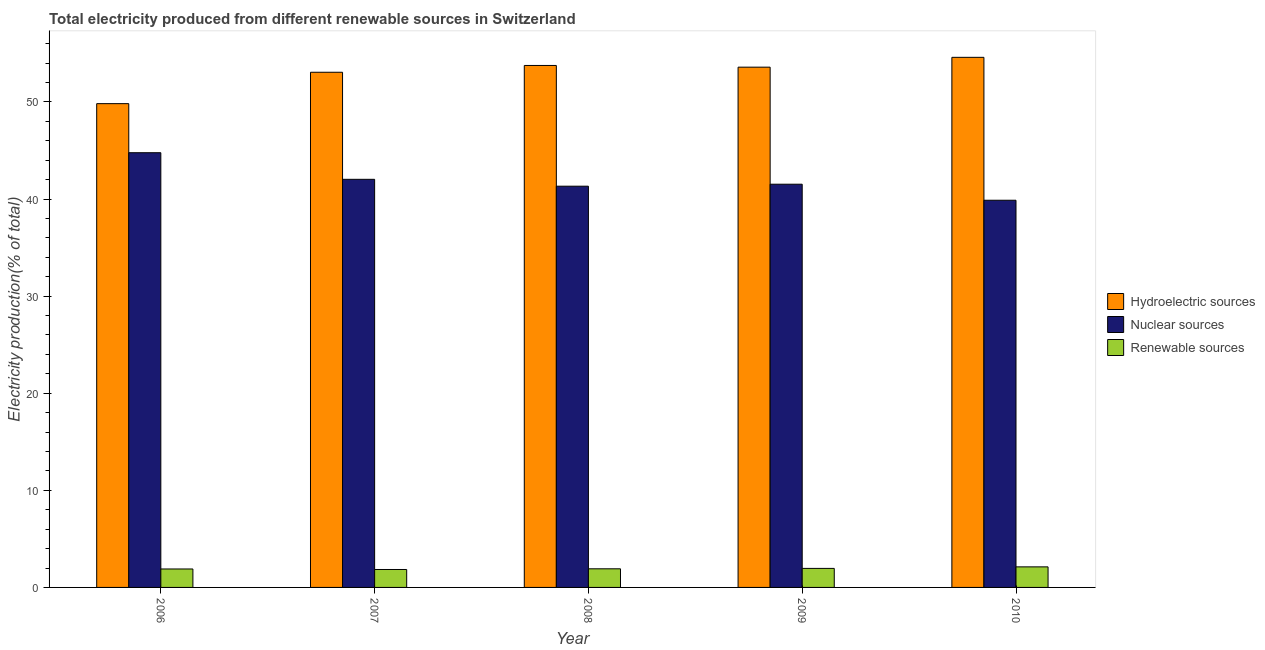How many groups of bars are there?
Ensure brevity in your answer.  5. Are the number of bars on each tick of the X-axis equal?
Your answer should be compact. Yes. How many bars are there on the 1st tick from the right?
Your response must be concise. 3. What is the label of the 5th group of bars from the left?
Give a very brief answer. 2010. What is the percentage of electricity produced by hydroelectric sources in 2008?
Offer a terse response. 53.76. Across all years, what is the maximum percentage of electricity produced by renewable sources?
Your response must be concise. 2.12. Across all years, what is the minimum percentage of electricity produced by renewable sources?
Ensure brevity in your answer.  1.85. In which year was the percentage of electricity produced by nuclear sources minimum?
Give a very brief answer. 2010. What is the total percentage of electricity produced by renewable sources in the graph?
Your answer should be compact. 9.74. What is the difference between the percentage of electricity produced by hydroelectric sources in 2006 and that in 2008?
Provide a short and direct response. -3.93. What is the difference between the percentage of electricity produced by hydroelectric sources in 2007 and the percentage of electricity produced by nuclear sources in 2009?
Make the answer very short. -0.52. What is the average percentage of electricity produced by hydroelectric sources per year?
Your answer should be compact. 52.96. In how many years, is the percentage of electricity produced by hydroelectric sources greater than 28 %?
Keep it short and to the point. 5. What is the ratio of the percentage of electricity produced by nuclear sources in 2007 to that in 2009?
Ensure brevity in your answer.  1.01. Is the percentage of electricity produced by renewable sources in 2006 less than that in 2009?
Provide a short and direct response. Yes. What is the difference between the highest and the second highest percentage of electricity produced by renewable sources?
Provide a succinct answer. 0.16. What is the difference between the highest and the lowest percentage of electricity produced by hydroelectric sources?
Keep it short and to the point. 4.77. What does the 1st bar from the left in 2009 represents?
Provide a succinct answer. Hydroelectric sources. What does the 3rd bar from the right in 2006 represents?
Keep it short and to the point. Hydroelectric sources. How many bars are there?
Offer a terse response. 15. Are all the bars in the graph horizontal?
Make the answer very short. No. How many years are there in the graph?
Make the answer very short. 5. What is the difference between two consecutive major ticks on the Y-axis?
Provide a succinct answer. 10. Does the graph contain any zero values?
Ensure brevity in your answer.  No. Does the graph contain grids?
Ensure brevity in your answer.  No. Where does the legend appear in the graph?
Make the answer very short. Center right. How are the legend labels stacked?
Keep it short and to the point. Vertical. What is the title of the graph?
Ensure brevity in your answer.  Total electricity produced from different renewable sources in Switzerland. Does "Labor Market" appear as one of the legend labels in the graph?
Offer a very short reply. No. What is the Electricity production(% of total) of Hydroelectric sources in 2006?
Make the answer very short. 49.83. What is the Electricity production(% of total) in Nuclear sources in 2006?
Your answer should be compact. 44.77. What is the Electricity production(% of total) in Renewable sources in 2006?
Keep it short and to the point. 1.9. What is the Electricity production(% of total) in Hydroelectric sources in 2007?
Offer a very short reply. 53.06. What is the Electricity production(% of total) of Nuclear sources in 2007?
Provide a succinct answer. 42.03. What is the Electricity production(% of total) in Renewable sources in 2007?
Ensure brevity in your answer.  1.85. What is the Electricity production(% of total) in Hydroelectric sources in 2008?
Provide a succinct answer. 53.76. What is the Electricity production(% of total) in Nuclear sources in 2008?
Ensure brevity in your answer.  41.32. What is the Electricity production(% of total) in Renewable sources in 2008?
Provide a succinct answer. 1.92. What is the Electricity production(% of total) of Hydroelectric sources in 2009?
Give a very brief answer. 53.58. What is the Electricity production(% of total) in Nuclear sources in 2009?
Your answer should be compact. 41.53. What is the Electricity production(% of total) of Renewable sources in 2009?
Provide a short and direct response. 1.96. What is the Electricity production(% of total) of Hydroelectric sources in 2010?
Provide a short and direct response. 54.6. What is the Electricity production(% of total) of Nuclear sources in 2010?
Give a very brief answer. 39.88. What is the Electricity production(% of total) of Renewable sources in 2010?
Provide a short and direct response. 2.12. Across all years, what is the maximum Electricity production(% of total) of Hydroelectric sources?
Provide a succinct answer. 54.6. Across all years, what is the maximum Electricity production(% of total) of Nuclear sources?
Your response must be concise. 44.77. Across all years, what is the maximum Electricity production(% of total) in Renewable sources?
Give a very brief answer. 2.12. Across all years, what is the minimum Electricity production(% of total) of Hydroelectric sources?
Offer a terse response. 49.83. Across all years, what is the minimum Electricity production(% of total) of Nuclear sources?
Keep it short and to the point. 39.88. Across all years, what is the minimum Electricity production(% of total) in Renewable sources?
Keep it short and to the point. 1.85. What is the total Electricity production(% of total) of Hydroelectric sources in the graph?
Offer a very short reply. 264.82. What is the total Electricity production(% of total) of Nuclear sources in the graph?
Offer a very short reply. 209.53. What is the total Electricity production(% of total) of Renewable sources in the graph?
Keep it short and to the point. 9.74. What is the difference between the Electricity production(% of total) of Hydroelectric sources in 2006 and that in 2007?
Make the answer very short. -3.23. What is the difference between the Electricity production(% of total) in Nuclear sources in 2006 and that in 2007?
Provide a short and direct response. 2.74. What is the difference between the Electricity production(% of total) in Renewable sources in 2006 and that in 2007?
Your response must be concise. 0.05. What is the difference between the Electricity production(% of total) of Hydroelectric sources in 2006 and that in 2008?
Provide a succinct answer. -3.93. What is the difference between the Electricity production(% of total) of Nuclear sources in 2006 and that in 2008?
Give a very brief answer. 3.45. What is the difference between the Electricity production(% of total) of Renewable sources in 2006 and that in 2008?
Offer a terse response. -0.02. What is the difference between the Electricity production(% of total) of Hydroelectric sources in 2006 and that in 2009?
Ensure brevity in your answer.  -3.76. What is the difference between the Electricity production(% of total) in Nuclear sources in 2006 and that in 2009?
Give a very brief answer. 3.24. What is the difference between the Electricity production(% of total) of Renewable sources in 2006 and that in 2009?
Provide a short and direct response. -0.06. What is the difference between the Electricity production(% of total) in Hydroelectric sources in 2006 and that in 2010?
Give a very brief answer. -4.77. What is the difference between the Electricity production(% of total) of Nuclear sources in 2006 and that in 2010?
Your response must be concise. 4.9. What is the difference between the Electricity production(% of total) in Renewable sources in 2006 and that in 2010?
Ensure brevity in your answer.  -0.22. What is the difference between the Electricity production(% of total) in Hydroelectric sources in 2007 and that in 2008?
Give a very brief answer. -0.7. What is the difference between the Electricity production(% of total) of Nuclear sources in 2007 and that in 2008?
Ensure brevity in your answer.  0.71. What is the difference between the Electricity production(% of total) of Renewable sources in 2007 and that in 2008?
Offer a terse response. -0.07. What is the difference between the Electricity production(% of total) of Hydroelectric sources in 2007 and that in 2009?
Make the answer very short. -0.52. What is the difference between the Electricity production(% of total) of Nuclear sources in 2007 and that in 2009?
Keep it short and to the point. 0.5. What is the difference between the Electricity production(% of total) in Renewable sources in 2007 and that in 2009?
Offer a terse response. -0.11. What is the difference between the Electricity production(% of total) of Hydroelectric sources in 2007 and that in 2010?
Give a very brief answer. -1.54. What is the difference between the Electricity production(% of total) in Nuclear sources in 2007 and that in 2010?
Provide a short and direct response. 2.16. What is the difference between the Electricity production(% of total) of Renewable sources in 2007 and that in 2010?
Make the answer very short. -0.27. What is the difference between the Electricity production(% of total) in Hydroelectric sources in 2008 and that in 2009?
Keep it short and to the point. 0.18. What is the difference between the Electricity production(% of total) in Nuclear sources in 2008 and that in 2009?
Provide a short and direct response. -0.2. What is the difference between the Electricity production(% of total) in Renewable sources in 2008 and that in 2009?
Ensure brevity in your answer.  -0.04. What is the difference between the Electricity production(% of total) in Hydroelectric sources in 2008 and that in 2010?
Offer a very short reply. -0.84. What is the difference between the Electricity production(% of total) in Nuclear sources in 2008 and that in 2010?
Provide a short and direct response. 1.45. What is the difference between the Electricity production(% of total) of Renewable sources in 2008 and that in 2010?
Keep it short and to the point. -0.2. What is the difference between the Electricity production(% of total) in Hydroelectric sources in 2009 and that in 2010?
Provide a succinct answer. -1.01. What is the difference between the Electricity production(% of total) in Nuclear sources in 2009 and that in 2010?
Provide a succinct answer. 1.65. What is the difference between the Electricity production(% of total) in Renewable sources in 2009 and that in 2010?
Keep it short and to the point. -0.16. What is the difference between the Electricity production(% of total) in Hydroelectric sources in 2006 and the Electricity production(% of total) in Nuclear sources in 2007?
Provide a succinct answer. 7.79. What is the difference between the Electricity production(% of total) of Hydroelectric sources in 2006 and the Electricity production(% of total) of Renewable sources in 2007?
Provide a succinct answer. 47.98. What is the difference between the Electricity production(% of total) of Nuclear sources in 2006 and the Electricity production(% of total) of Renewable sources in 2007?
Keep it short and to the point. 42.92. What is the difference between the Electricity production(% of total) in Hydroelectric sources in 2006 and the Electricity production(% of total) in Nuclear sources in 2008?
Provide a succinct answer. 8.5. What is the difference between the Electricity production(% of total) of Hydroelectric sources in 2006 and the Electricity production(% of total) of Renewable sources in 2008?
Give a very brief answer. 47.91. What is the difference between the Electricity production(% of total) in Nuclear sources in 2006 and the Electricity production(% of total) in Renewable sources in 2008?
Provide a short and direct response. 42.85. What is the difference between the Electricity production(% of total) of Hydroelectric sources in 2006 and the Electricity production(% of total) of Nuclear sources in 2009?
Offer a terse response. 8.3. What is the difference between the Electricity production(% of total) of Hydroelectric sources in 2006 and the Electricity production(% of total) of Renewable sources in 2009?
Your response must be concise. 47.87. What is the difference between the Electricity production(% of total) of Nuclear sources in 2006 and the Electricity production(% of total) of Renewable sources in 2009?
Keep it short and to the point. 42.81. What is the difference between the Electricity production(% of total) of Hydroelectric sources in 2006 and the Electricity production(% of total) of Nuclear sources in 2010?
Provide a succinct answer. 9.95. What is the difference between the Electricity production(% of total) in Hydroelectric sources in 2006 and the Electricity production(% of total) in Renewable sources in 2010?
Make the answer very short. 47.71. What is the difference between the Electricity production(% of total) of Nuclear sources in 2006 and the Electricity production(% of total) of Renewable sources in 2010?
Provide a short and direct response. 42.65. What is the difference between the Electricity production(% of total) of Hydroelectric sources in 2007 and the Electricity production(% of total) of Nuclear sources in 2008?
Keep it short and to the point. 11.73. What is the difference between the Electricity production(% of total) in Hydroelectric sources in 2007 and the Electricity production(% of total) in Renewable sources in 2008?
Your answer should be compact. 51.14. What is the difference between the Electricity production(% of total) in Nuclear sources in 2007 and the Electricity production(% of total) in Renewable sources in 2008?
Provide a succinct answer. 40.11. What is the difference between the Electricity production(% of total) in Hydroelectric sources in 2007 and the Electricity production(% of total) in Nuclear sources in 2009?
Provide a short and direct response. 11.53. What is the difference between the Electricity production(% of total) of Hydroelectric sources in 2007 and the Electricity production(% of total) of Renewable sources in 2009?
Your answer should be very brief. 51.1. What is the difference between the Electricity production(% of total) in Nuclear sources in 2007 and the Electricity production(% of total) in Renewable sources in 2009?
Your answer should be very brief. 40.07. What is the difference between the Electricity production(% of total) in Hydroelectric sources in 2007 and the Electricity production(% of total) in Nuclear sources in 2010?
Provide a succinct answer. 13.18. What is the difference between the Electricity production(% of total) in Hydroelectric sources in 2007 and the Electricity production(% of total) in Renewable sources in 2010?
Your answer should be very brief. 50.94. What is the difference between the Electricity production(% of total) of Nuclear sources in 2007 and the Electricity production(% of total) of Renewable sources in 2010?
Your answer should be very brief. 39.91. What is the difference between the Electricity production(% of total) of Hydroelectric sources in 2008 and the Electricity production(% of total) of Nuclear sources in 2009?
Offer a very short reply. 12.23. What is the difference between the Electricity production(% of total) of Hydroelectric sources in 2008 and the Electricity production(% of total) of Renewable sources in 2009?
Your answer should be compact. 51.8. What is the difference between the Electricity production(% of total) of Nuclear sources in 2008 and the Electricity production(% of total) of Renewable sources in 2009?
Ensure brevity in your answer.  39.36. What is the difference between the Electricity production(% of total) in Hydroelectric sources in 2008 and the Electricity production(% of total) in Nuclear sources in 2010?
Ensure brevity in your answer.  13.88. What is the difference between the Electricity production(% of total) of Hydroelectric sources in 2008 and the Electricity production(% of total) of Renewable sources in 2010?
Provide a short and direct response. 51.64. What is the difference between the Electricity production(% of total) of Nuclear sources in 2008 and the Electricity production(% of total) of Renewable sources in 2010?
Make the answer very short. 39.2. What is the difference between the Electricity production(% of total) of Hydroelectric sources in 2009 and the Electricity production(% of total) of Nuclear sources in 2010?
Provide a succinct answer. 13.71. What is the difference between the Electricity production(% of total) in Hydroelectric sources in 2009 and the Electricity production(% of total) in Renewable sources in 2010?
Provide a short and direct response. 51.46. What is the difference between the Electricity production(% of total) of Nuclear sources in 2009 and the Electricity production(% of total) of Renewable sources in 2010?
Ensure brevity in your answer.  39.41. What is the average Electricity production(% of total) in Hydroelectric sources per year?
Make the answer very short. 52.96. What is the average Electricity production(% of total) in Nuclear sources per year?
Ensure brevity in your answer.  41.91. What is the average Electricity production(% of total) in Renewable sources per year?
Give a very brief answer. 1.95. In the year 2006, what is the difference between the Electricity production(% of total) in Hydroelectric sources and Electricity production(% of total) in Nuclear sources?
Your answer should be very brief. 5.05. In the year 2006, what is the difference between the Electricity production(% of total) of Hydroelectric sources and Electricity production(% of total) of Renewable sources?
Provide a succinct answer. 47.92. In the year 2006, what is the difference between the Electricity production(% of total) in Nuclear sources and Electricity production(% of total) in Renewable sources?
Give a very brief answer. 42.87. In the year 2007, what is the difference between the Electricity production(% of total) in Hydroelectric sources and Electricity production(% of total) in Nuclear sources?
Your response must be concise. 11.03. In the year 2007, what is the difference between the Electricity production(% of total) of Hydroelectric sources and Electricity production(% of total) of Renewable sources?
Provide a succinct answer. 51.21. In the year 2007, what is the difference between the Electricity production(% of total) in Nuclear sources and Electricity production(% of total) in Renewable sources?
Offer a terse response. 40.19. In the year 2008, what is the difference between the Electricity production(% of total) of Hydroelectric sources and Electricity production(% of total) of Nuclear sources?
Ensure brevity in your answer.  12.44. In the year 2008, what is the difference between the Electricity production(% of total) of Hydroelectric sources and Electricity production(% of total) of Renewable sources?
Keep it short and to the point. 51.84. In the year 2008, what is the difference between the Electricity production(% of total) of Nuclear sources and Electricity production(% of total) of Renewable sources?
Offer a very short reply. 39.4. In the year 2009, what is the difference between the Electricity production(% of total) of Hydroelectric sources and Electricity production(% of total) of Nuclear sources?
Give a very brief answer. 12.06. In the year 2009, what is the difference between the Electricity production(% of total) in Hydroelectric sources and Electricity production(% of total) in Renewable sources?
Provide a succinct answer. 51.62. In the year 2009, what is the difference between the Electricity production(% of total) of Nuclear sources and Electricity production(% of total) of Renewable sources?
Your answer should be very brief. 39.57. In the year 2010, what is the difference between the Electricity production(% of total) of Hydroelectric sources and Electricity production(% of total) of Nuclear sources?
Give a very brief answer. 14.72. In the year 2010, what is the difference between the Electricity production(% of total) of Hydroelectric sources and Electricity production(% of total) of Renewable sources?
Keep it short and to the point. 52.48. In the year 2010, what is the difference between the Electricity production(% of total) in Nuclear sources and Electricity production(% of total) in Renewable sources?
Ensure brevity in your answer.  37.76. What is the ratio of the Electricity production(% of total) of Hydroelectric sources in 2006 to that in 2007?
Make the answer very short. 0.94. What is the ratio of the Electricity production(% of total) of Nuclear sources in 2006 to that in 2007?
Ensure brevity in your answer.  1.07. What is the ratio of the Electricity production(% of total) of Renewable sources in 2006 to that in 2007?
Your answer should be very brief. 1.03. What is the ratio of the Electricity production(% of total) of Hydroelectric sources in 2006 to that in 2008?
Ensure brevity in your answer.  0.93. What is the ratio of the Electricity production(% of total) of Nuclear sources in 2006 to that in 2008?
Give a very brief answer. 1.08. What is the ratio of the Electricity production(% of total) of Renewable sources in 2006 to that in 2008?
Give a very brief answer. 0.99. What is the ratio of the Electricity production(% of total) of Hydroelectric sources in 2006 to that in 2009?
Provide a short and direct response. 0.93. What is the ratio of the Electricity production(% of total) of Nuclear sources in 2006 to that in 2009?
Provide a succinct answer. 1.08. What is the ratio of the Electricity production(% of total) of Renewable sources in 2006 to that in 2009?
Provide a succinct answer. 0.97. What is the ratio of the Electricity production(% of total) of Hydroelectric sources in 2006 to that in 2010?
Your response must be concise. 0.91. What is the ratio of the Electricity production(% of total) of Nuclear sources in 2006 to that in 2010?
Provide a short and direct response. 1.12. What is the ratio of the Electricity production(% of total) in Renewable sources in 2006 to that in 2010?
Offer a very short reply. 0.9. What is the ratio of the Electricity production(% of total) of Hydroelectric sources in 2007 to that in 2008?
Your response must be concise. 0.99. What is the ratio of the Electricity production(% of total) in Nuclear sources in 2007 to that in 2008?
Provide a succinct answer. 1.02. What is the ratio of the Electricity production(% of total) of Renewable sources in 2007 to that in 2008?
Provide a succinct answer. 0.96. What is the ratio of the Electricity production(% of total) of Hydroelectric sources in 2007 to that in 2009?
Ensure brevity in your answer.  0.99. What is the ratio of the Electricity production(% of total) in Nuclear sources in 2007 to that in 2009?
Provide a succinct answer. 1.01. What is the ratio of the Electricity production(% of total) in Renewable sources in 2007 to that in 2009?
Your answer should be compact. 0.94. What is the ratio of the Electricity production(% of total) of Hydroelectric sources in 2007 to that in 2010?
Provide a short and direct response. 0.97. What is the ratio of the Electricity production(% of total) in Nuclear sources in 2007 to that in 2010?
Offer a very short reply. 1.05. What is the ratio of the Electricity production(% of total) of Renewable sources in 2007 to that in 2010?
Your answer should be very brief. 0.87. What is the ratio of the Electricity production(% of total) in Hydroelectric sources in 2008 to that in 2009?
Provide a succinct answer. 1. What is the ratio of the Electricity production(% of total) in Nuclear sources in 2008 to that in 2009?
Offer a terse response. 1. What is the ratio of the Electricity production(% of total) of Renewable sources in 2008 to that in 2009?
Your answer should be very brief. 0.98. What is the ratio of the Electricity production(% of total) in Hydroelectric sources in 2008 to that in 2010?
Your response must be concise. 0.98. What is the ratio of the Electricity production(% of total) of Nuclear sources in 2008 to that in 2010?
Make the answer very short. 1.04. What is the ratio of the Electricity production(% of total) in Renewable sources in 2008 to that in 2010?
Ensure brevity in your answer.  0.91. What is the ratio of the Electricity production(% of total) of Hydroelectric sources in 2009 to that in 2010?
Your answer should be compact. 0.98. What is the ratio of the Electricity production(% of total) in Nuclear sources in 2009 to that in 2010?
Offer a terse response. 1.04. What is the ratio of the Electricity production(% of total) of Renewable sources in 2009 to that in 2010?
Your answer should be compact. 0.92. What is the difference between the highest and the second highest Electricity production(% of total) in Hydroelectric sources?
Your response must be concise. 0.84. What is the difference between the highest and the second highest Electricity production(% of total) in Nuclear sources?
Keep it short and to the point. 2.74. What is the difference between the highest and the second highest Electricity production(% of total) in Renewable sources?
Give a very brief answer. 0.16. What is the difference between the highest and the lowest Electricity production(% of total) in Hydroelectric sources?
Your response must be concise. 4.77. What is the difference between the highest and the lowest Electricity production(% of total) in Nuclear sources?
Offer a very short reply. 4.9. What is the difference between the highest and the lowest Electricity production(% of total) in Renewable sources?
Offer a terse response. 0.27. 